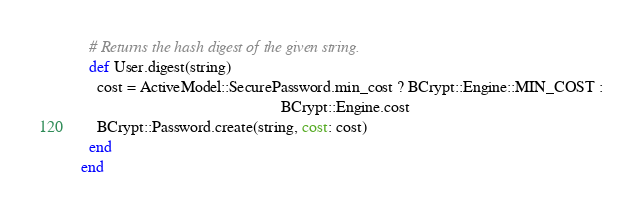<code> <loc_0><loc_0><loc_500><loc_500><_Ruby_>  # Returns the hash digest of the given string.
  def User.digest(string)
    cost = ActiveModel::SecurePassword.min_cost ? BCrypt::Engine::MIN_COST :
                                                  BCrypt::Engine.cost
    BCrypt::Password.create(string, cost: cost)
  end
end
</code> 